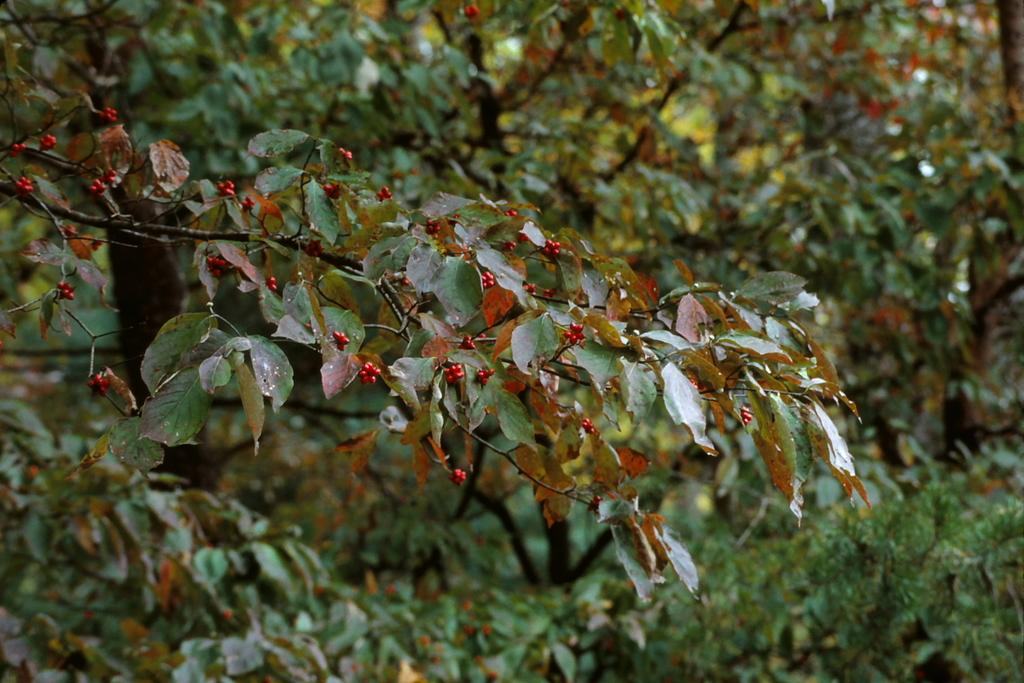What is the main subject in the center of the image? There is a stem with berries and leaves in the center of the image. What can be seen in the background of the image? There are trees in the background of the image. What type of island can be seen in the background of the image? There is no island present in the image; it features a stem with berries and leaves in the center and trees in the background. 